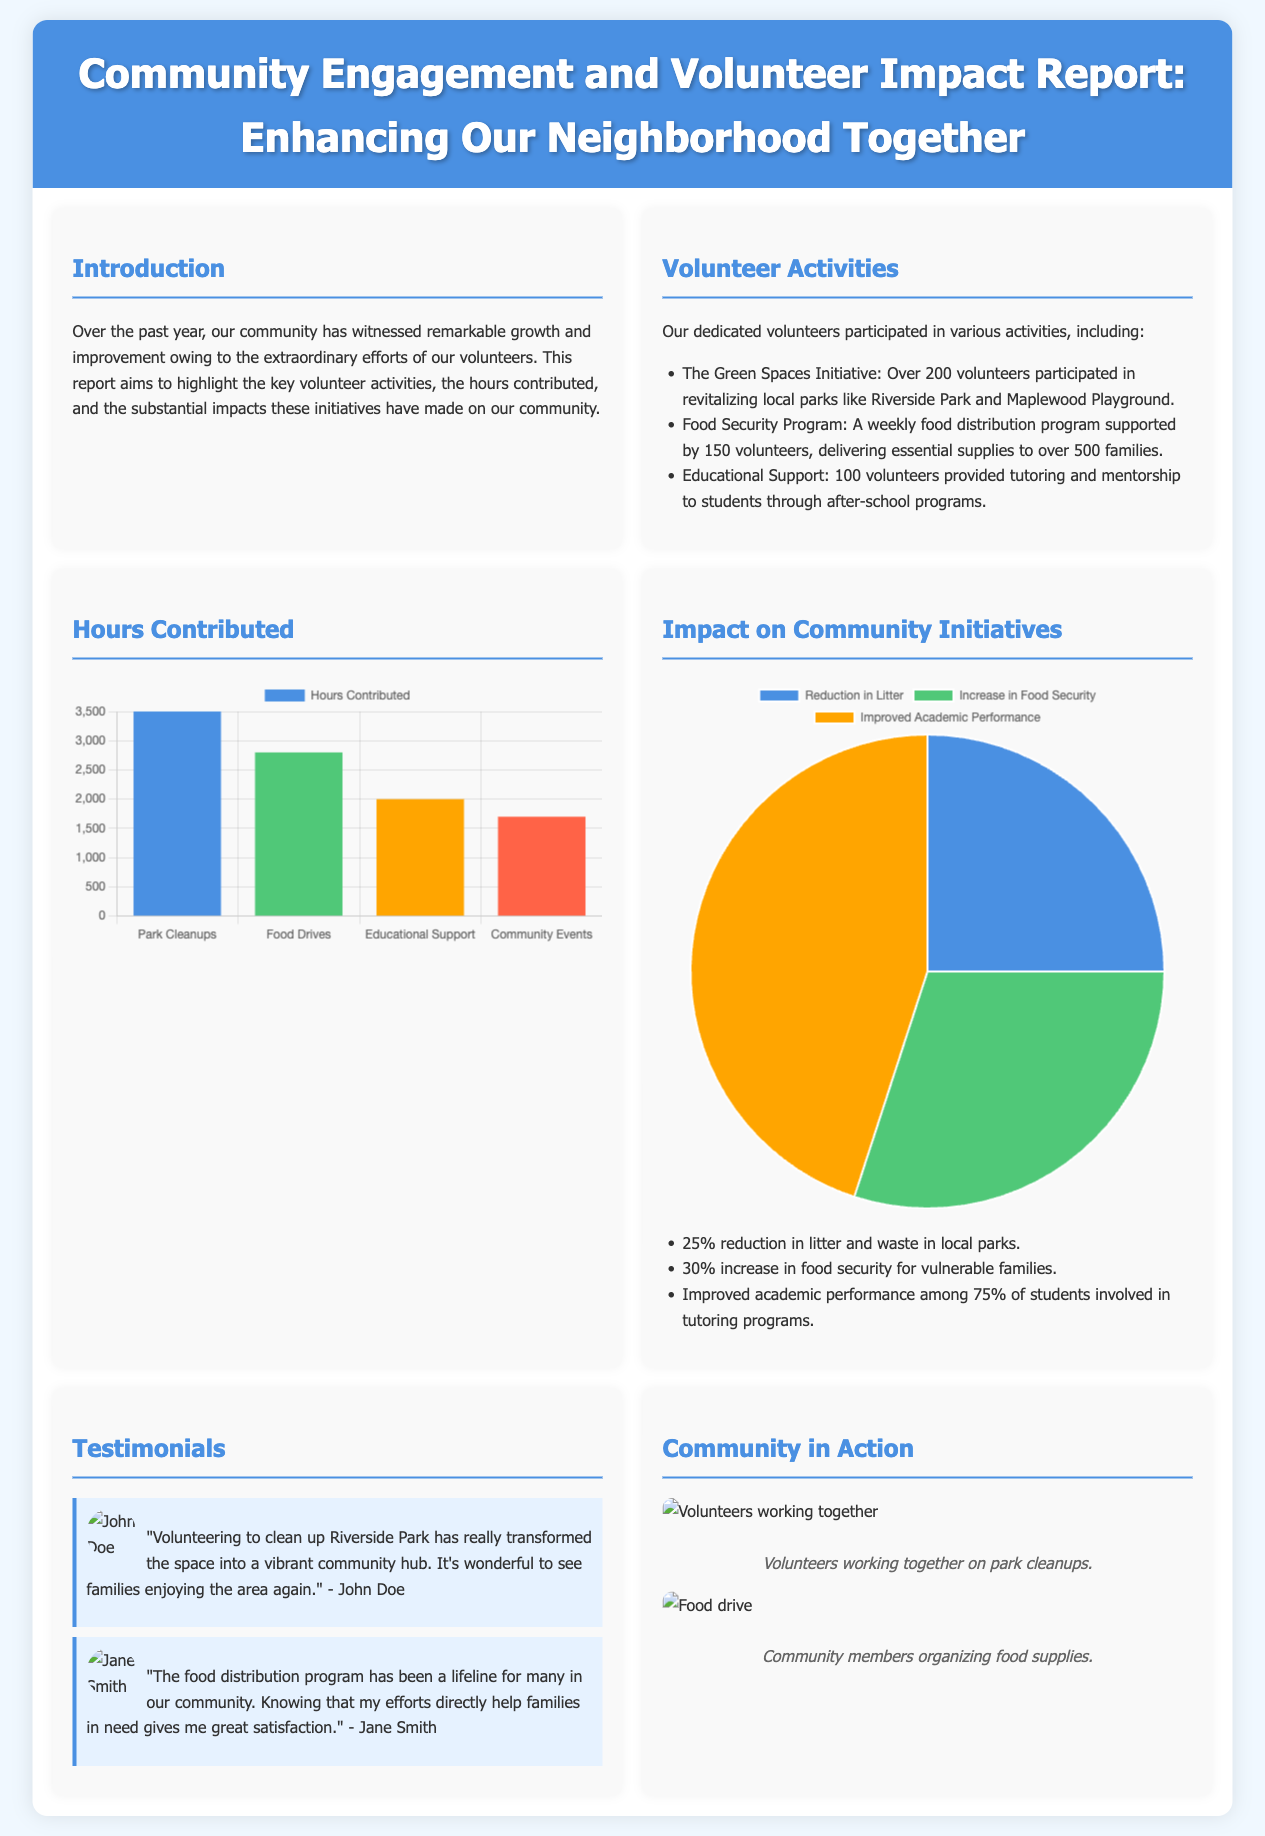What is the total number of volunteers involved in the Green Spaces Initiative? The document states that over 200 volunteers participated in the Green Spaces Initiative.
Answer: 200 How many families benefit from the Food Security Program? The report indicates that essential supplies are delivered to over 500 families through the Food Security Program.
Answer: 500 What was the total number of hours contributed to Educational Support? According to the document, 2000 hours were contributed to Educational Support by volunteers.
Answer: 2000 What percentage of students showed improved academic performance? The document mentions that improved academic performance was observed among 75% of the students involved in tutoring programs.
Answer: 75% What is the main theme of the report? The report highlights the extraordinary efforts of volunteers and their impacts on community initiatives.
Answer: Community Engagement Which activity had the highest number of contributed hours? The report notes that Park Cleanups had the highest number of contributed hours totaling 3500.
Answer: 3500 What type of chart illustrates hours contributed? The hours contributed are illustrated using a bar chart in the report.
Answer: Bar Chart What was the percentage increase in food security for vulnerable families? The report states there was a 30% increase in food security for vulnerable families.
Answer: 30% How many testimonials are included in the document? There are two testimonials included in the report.
Answer: Two 